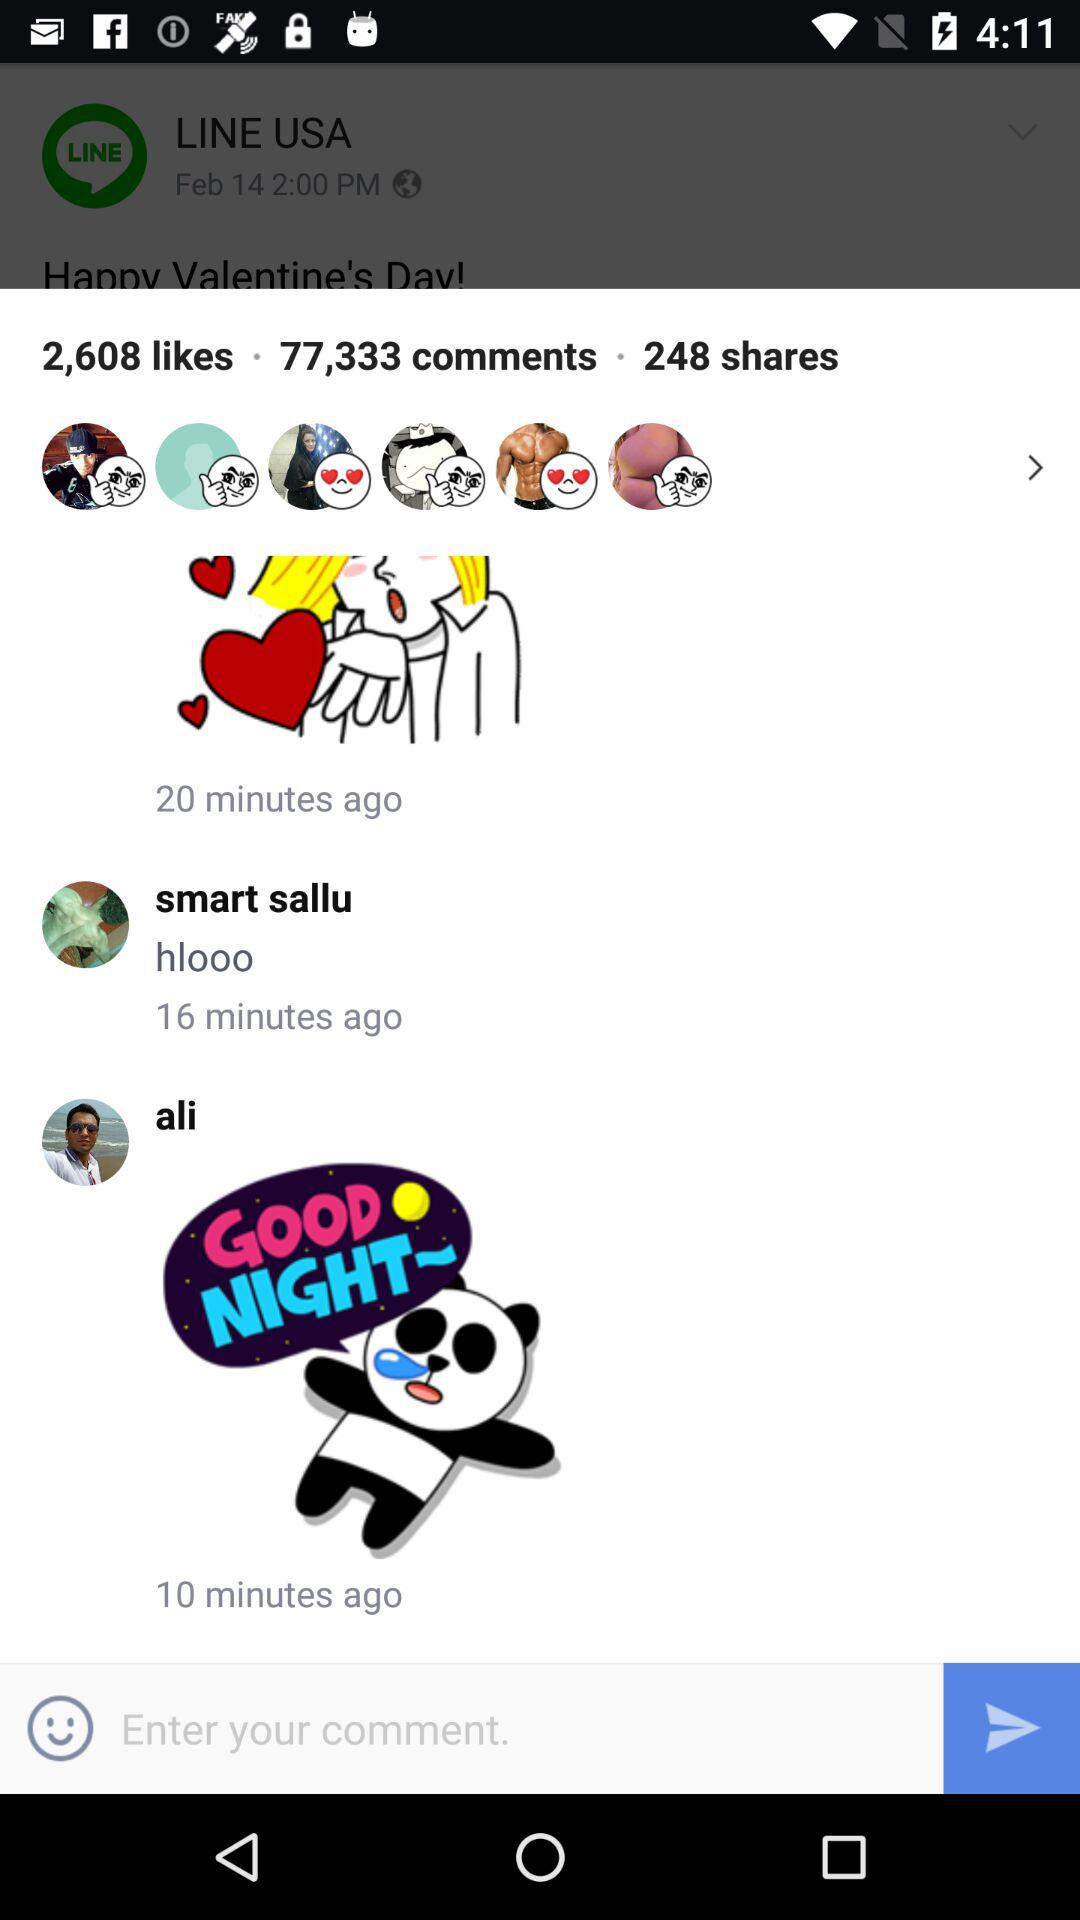How many comments were made more than 10 minutes ago?
Answer the question using a single word or phrase. 2 